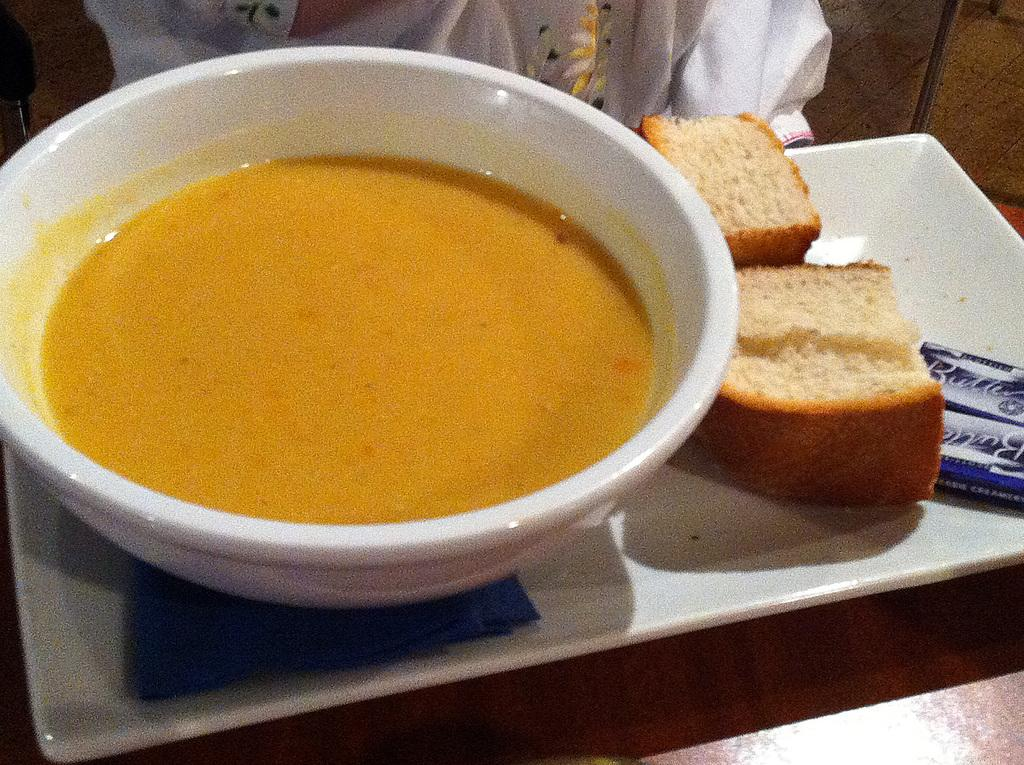What type of food can be seen in the image? There is bread and a bowl with food in the image. How are the bread and bowl arranged in the image? The bread and bowl are on a tray. Where is the tray located in the image? The tray is on a table. What type of destruction can be seen happening to the houses in the image? There are no houses present in the image, so no destruction can be observed. 